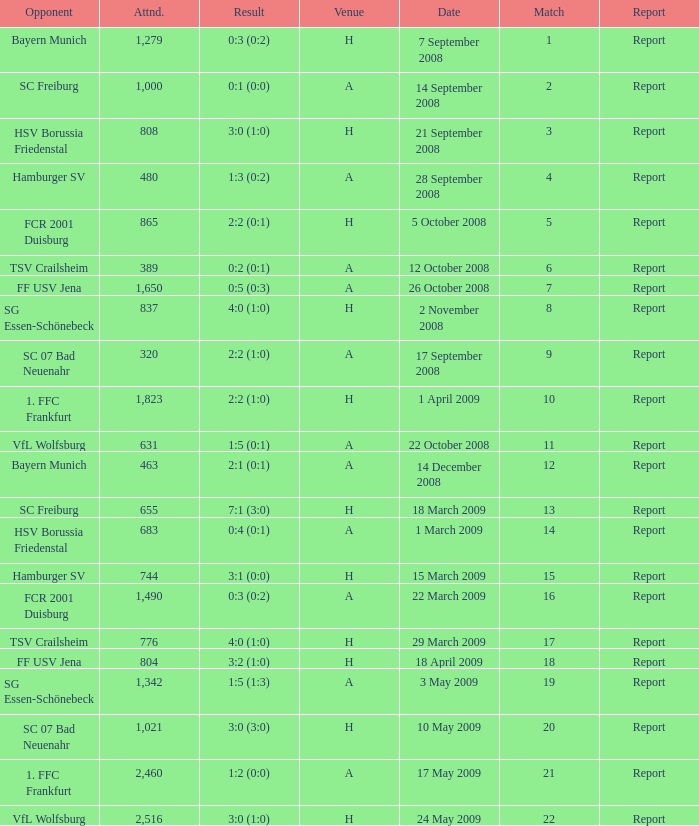What is the match number that had a result of 0:5 (0:3)? 1.0. 